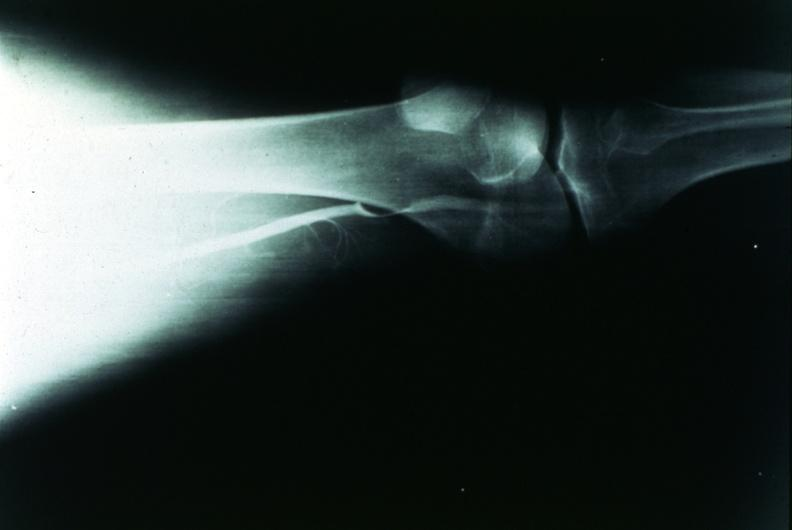does this image show popliteal cyst?
Answer the question using a single word or phrase. Yes 